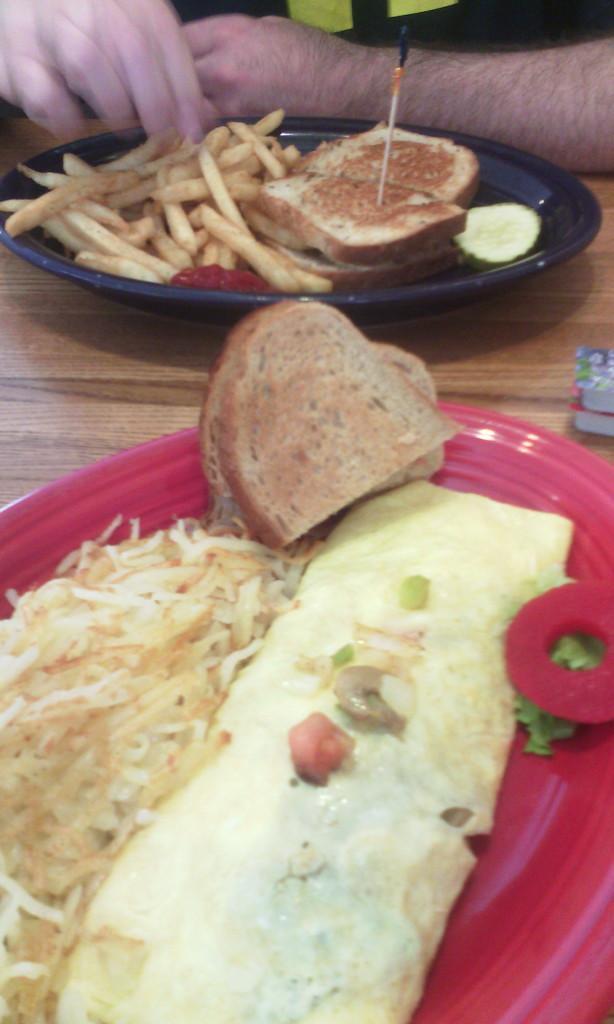How would you summarize this image in a sentence or two? In this picture I can see there are some plates here and there is some food places here in the plates and there is a person sitting in the backdrop. 